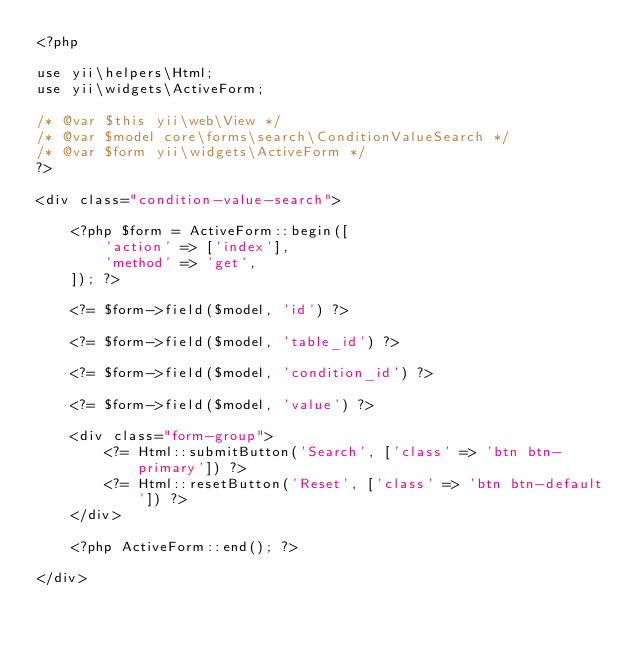<code> <loc_0><loc_0><loc_500><loc_500><_PHP_><?php

use yii\helpers\Html;
use yii\widgets\ActiveForm;

/* @var $this yii\web\View */
/* @var $model core\forms\search\ConditionValueSearch */
/* @var $form yii\widgets\ActiveForm */
?>

<div class="condition-value-search">

    <?php $form = ActiveForm::begin([
        'action' => ['index'],
        'method' => 'get',
    ]); ?>

    <?= $form->field($model, 'id') ?>

    <?= $form->field($model, 'table_id') ?>

    <?= $form->field($model, 'condition_id') ?>

    <?= $form->field($model, 'value') ?>

    <div class="form-group">
        <?= Html::submitButton('Search', ['class' => 'btn btn-primary']) ?>
        <?= Html::resetButton('Reset', ['class' => 'btn btn-default']) ?>
    </div>

    <?php ActiveForm::end(); ?>

</div>
</code> 